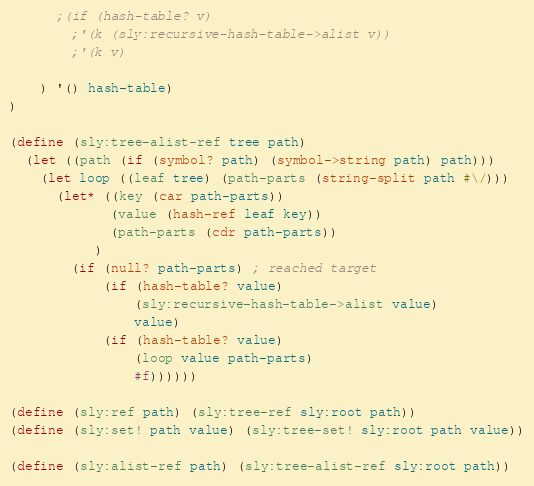Convert code to text. <code><loc_0><loc_0><loc_500><loc_500><_Scheme_>      ;(if (hash-table? v)
        ;'(k (sly:recursive-hash-table->alist v))
        ;'(k v)
      
    ) '() hash-table)
)

(define (sly:tree-alist-ref tree path)
  (let ((path (if (symbol? path) (symbol->string path) path)))
    (let loop ((leaf tree) (path-parts (string-split path #\/)))
      (let* ((key (car path-parts))
             (value (hash-ref leaf key))
             (path-parts (cdr path-parts))
           )
        (if (null? path-parts) ; reached target
            (if (hash-table? value)
                (sly:recursive-hash-table->alist value)
                value)
            (if (hash-table? value)
                (loop value path-parts)
                #f))))))

(define (sly:ref path) (sly:tree-ref sly:root path))
(define (sly:set! path value) (sly:tree-set! sly:root path value))

(define (sly:alist-ref path) (sly:tree-alist-ref sly:root path))</code> 